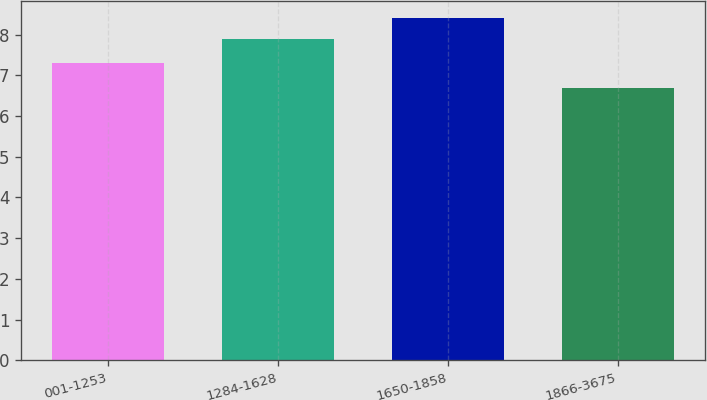Convert chart. <chart><loc_0><loc_0><loc_500><loc_500><bar_chart><fcel>001-1253<fcel>1284-1628<fcel>1650-1858<fcel>1866-3675<nl><fcel>7.3<fcel>7.9<fcel>8.4<fcel>6.7<nl></chart> 